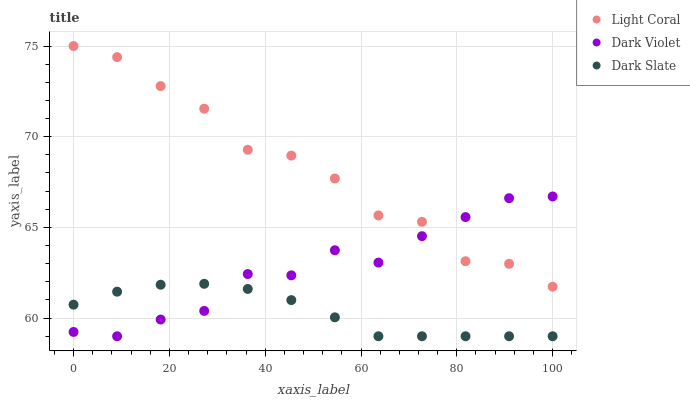Does Dark Slate have the minimum area under the curve?
Answer yes or no. Yes. Does Light Coral have the maximum area under the curve?
Answer yes or no. Yes. Does Dark Violet have the minimum area under the curve?
Answer yes or no. No. Does Dark Violet have the maximum area under the curve?
Answer yes or no. No. Is Dark Slate the smoothest?
Answer yes or no. Yes. Is Light Coral the roughest?
Answer yes or no. Yes. Is Dark Violet the smoothest?
Answer yes or no. No. Is Dark Violet the roughest?
Answer yes or no. No. Does Dark Slate have the lowest value?
Answer yes or no. Yes. Does Light Coral have the highest value?
Answer yes or no. Yes. Does Dark Violet have the highest value?
Answer yes or no. No. Is Dark Slate less than Light Coral?
Answer yes or no. Yes. Is Light Coral greater than Dark Slate?
Answer yes or no. Yes. Does Light Coral intersect Dark Violet?
Answer yes or no. Yes. Is Light Coral less than Dark Violet?
Answer yes or no. No. Is Light Coral greater than Dark Violet?
Answer yes or no. No. Does Dark Slate intersect Light Coral?
Answer yes or no. No. 